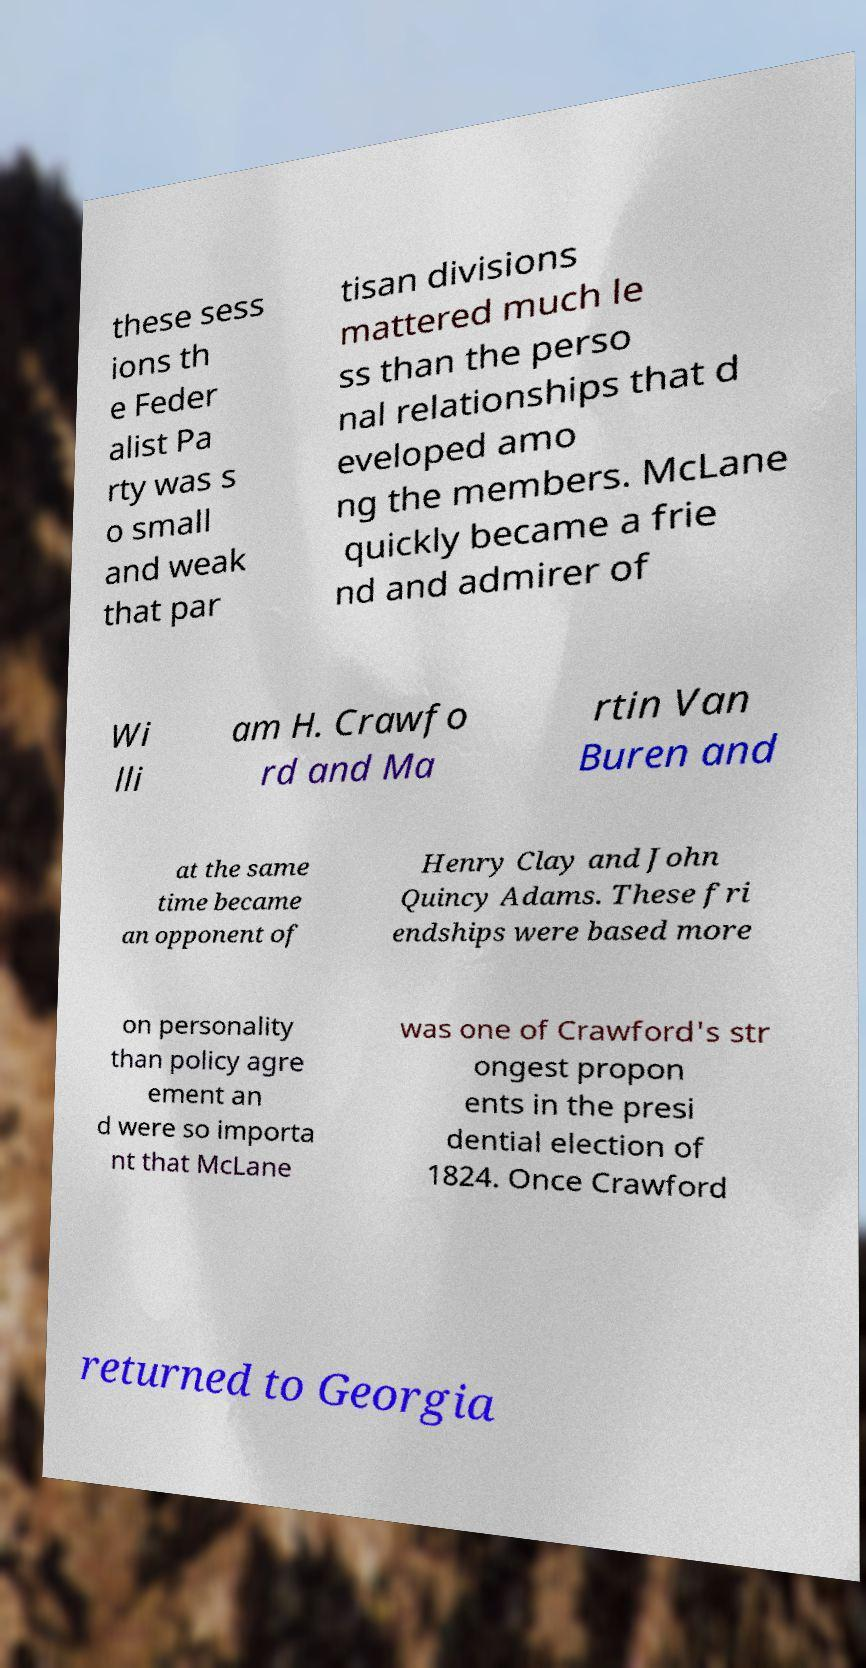For documentation purposes, I need the text within this image transcribed. Could you provide that? these sess ions th e Feder alist Pa rty was s o small and weak that par tisan divisions mattered much le ss than the perso nal relationships that d eveloped amo ng the members. McLane quickly became a frie nd and admirer of Wi lli am H. Crawfo rd and Ma rtin Van Buren and at the same time became an opponent of Henry Clay and John Quincy Adams. These fri endships were based more on personality than policy agre ement an d were so importa nt that McLane was one of Crawford's str ongest propon ents in the presi dential election of 1824. Once Crawford returned to Georgia 